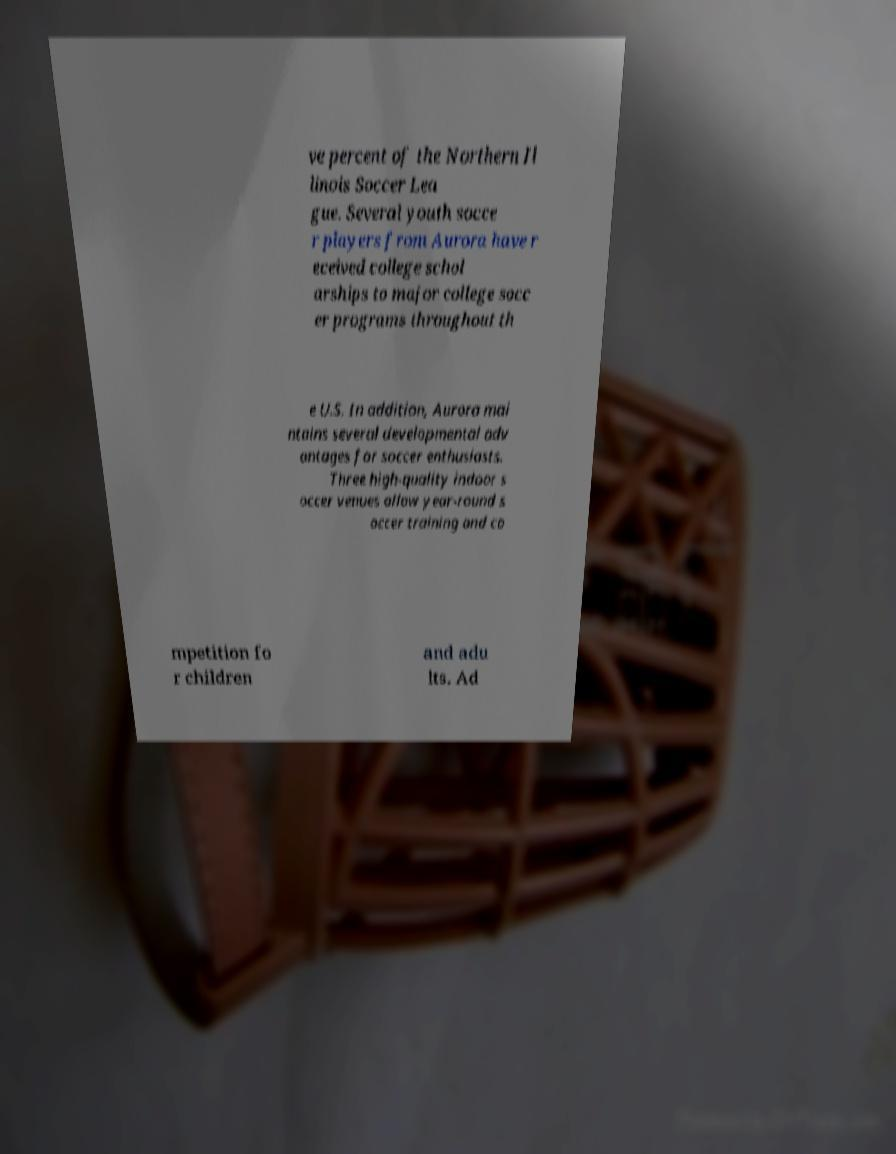There's text embedded in this image that I need extracted. Can you transcribe it verbatim? ve percent of the Northern Il linois Soccer Lea gue. Several youth socce r players from Aurora have r eceived college schol arships to major college socc er programs throughout th e U.S. In addition, Aurora mai ntains several developmental adv antages for soccer enthusiasts. Three high-quality indoor s occer venues allow year-round s occer training and co mpetition fo r children and adu lts. Ad 